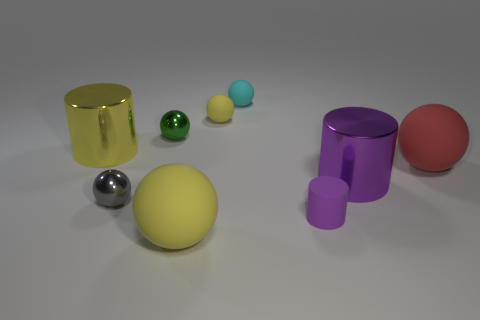There is a large metal cylinder left of the small green sphere; what color is it?
Your answer should be very brief. Yellow. How many other things are there of the same size as the purple metallic object?
Give a very brief answer. 3. What size is the ball that is both on the right side of the small yellow matte sphere and to the left of the large purple shiny thing?
Offer a very short reply. Small. There is a small rubber cylinder; is its color the same as the object in front of the small purple rubber cylinder?
Keep it short and to the point. No. Is there a cyan thing that has the same shape as the small gray shiny object?
Offer a very short reply. Yes. What number of objects are metal spheres or purple shiny objects in front of the big red thing?
Ensure brevity in your answer.  3. How many other things are the same material as the green object?
Provide a succinct answer. 3. How many things are either large yellow balls or big cyan shiny balls?
Ensure brevity in your answer.  1. Are there more tiny gray things that are behind the large red matte object than small matte things to the left of the large purple cylinder?
Your answer should be compact. No. Is the color of the rubber cylinder that is in front of the red thing the same as the big thing behind the big red ball?
Your answer should be compact. No. 